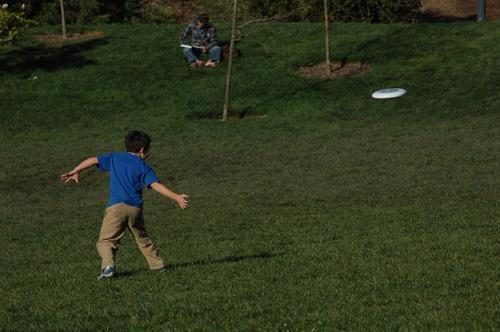How many people are watching the game?
Give a very brief answer. 1. How many kids are there?
Give a very brief answer. 1. How many people in the shot?
Give a very brief answer. 2. 